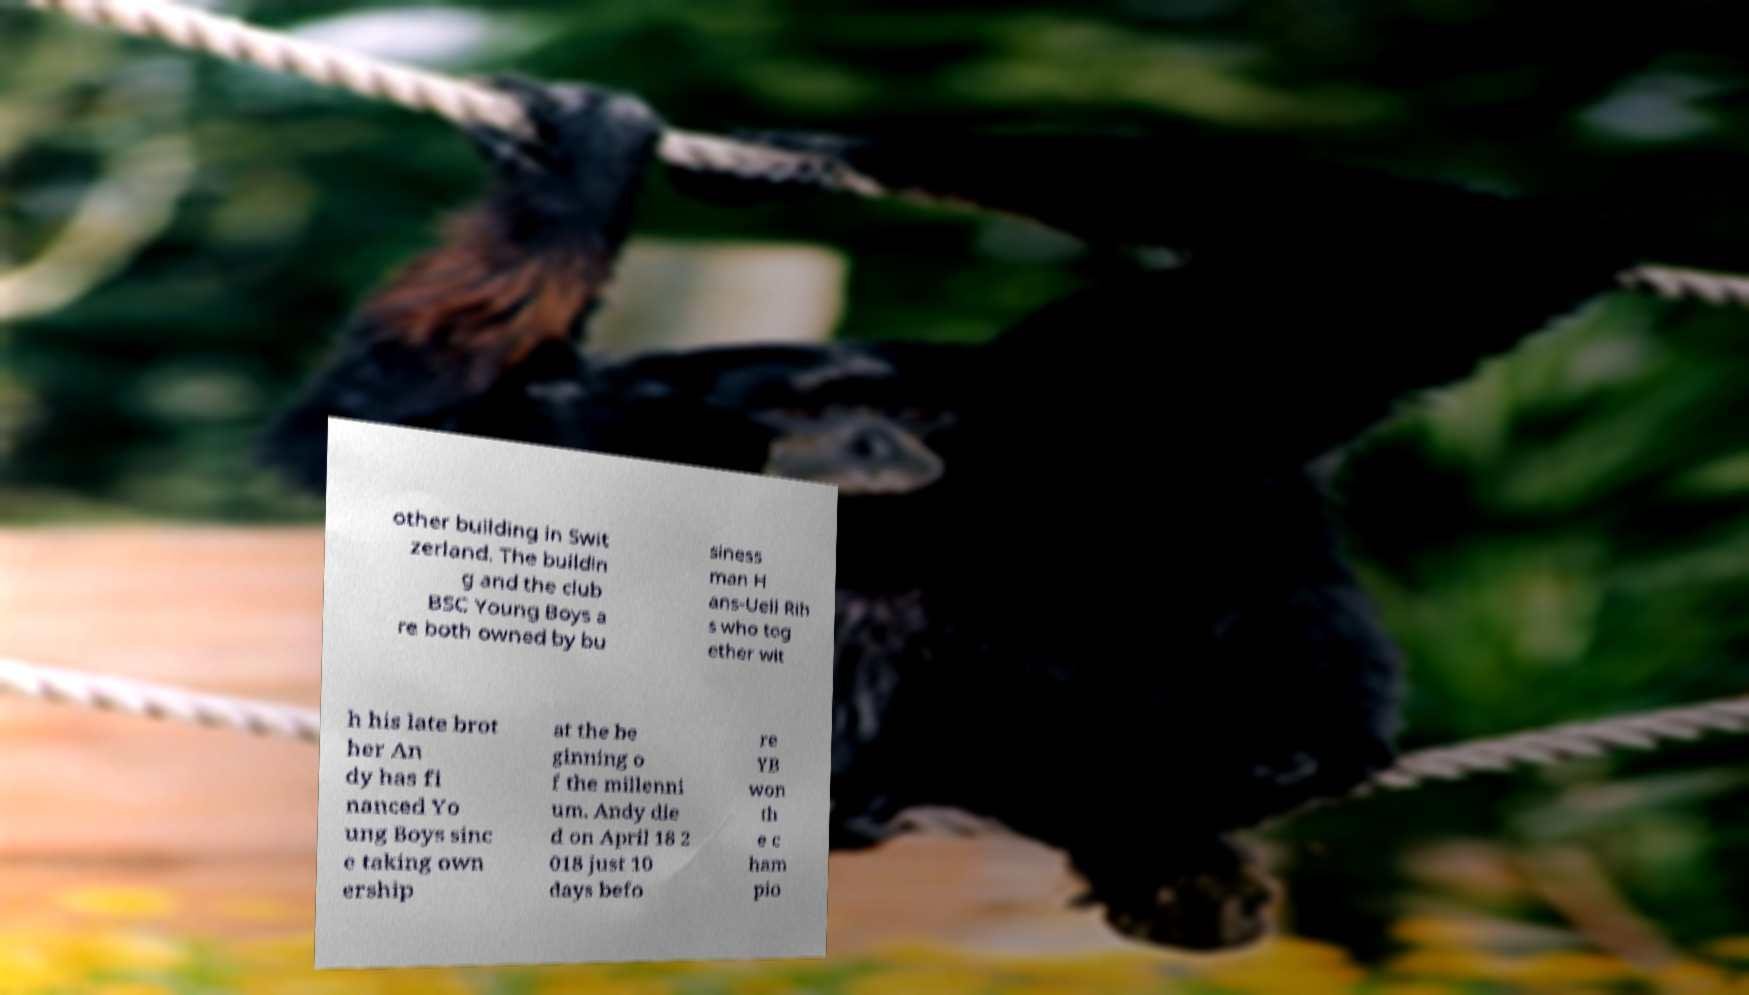Could you extract and type out the text from this image? other building in Swit zerland. The buildin g and the club BSC Young Boys a re both owned by bu siness man H ans-Ueli Rih s who tog ether wit h his late brot her An dy has fi nanced Yo ung Boys sinc e taking own ership at the be ginning o f the millenni um. Andy die d on April 18 2 018 just 10 days befo re YB won th e c ham pio 